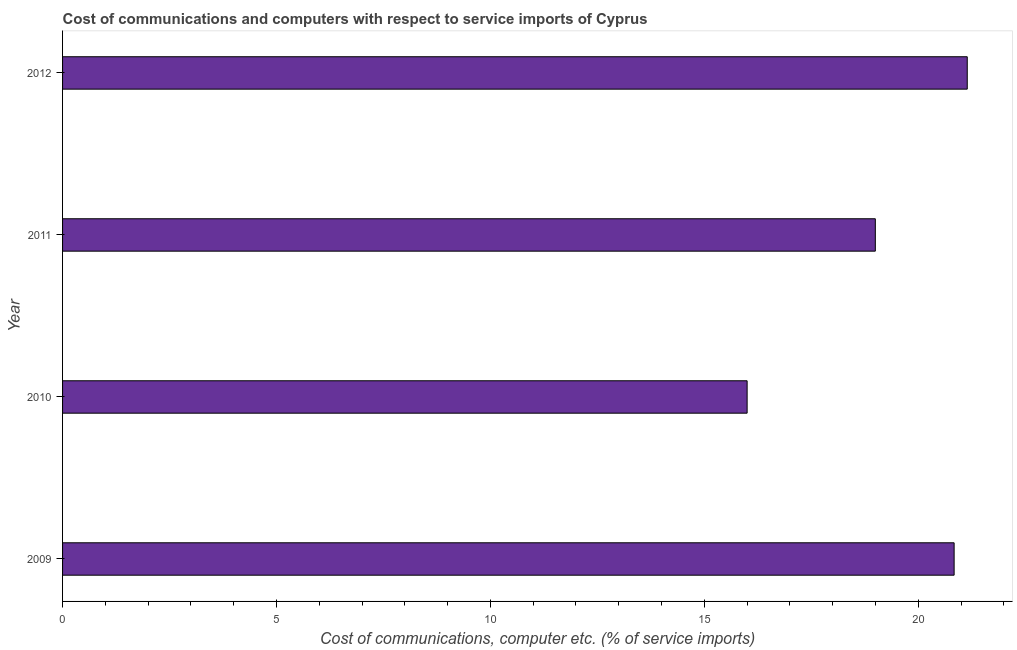Does the graph contain any zero values?
Keep it short and to the point. No. Does the graph contain grids?
Make the answer very short. No. What is the title of the graph?
Make the answer very short. Cost of communications and computers with respect to service imports of Cyprus. What is the label or title of the X-axis?
Keep it short and to the point. Cost of communications, computer etc. (% of service imports). What is the label or title of the Y-axis?
Your answer should be very brief. Year. What is the cost of communications and computer in 2009?
Make the answer very short. 20.84. Across all years, what is the maximum cost of communications and computer?
Provide a succinct answer. 21.15. Across all years, what is the minimum cost of communications and computer?
Provide a short and direct response. 16. What is the sum of the cost of communications and computer?
Your response must be concise. 76.98. What is the difference between the cost of communications and computer in 2009 and 2010?
Your response must be concise. 4.84. What is the average cost of communications and computer per year?
Give a very brief answer. 19.25. What is the median cost of communications and computer?
Keep it short and to the point. 19.92. In how many years, is the cost of communications and computer greater than 7 %?
Make the answer very short. 4. What is the ratio of the cost of communications and computer in 2010 to that in 2011?
Offer a very short reply. 0.84. Is the difference between the cost of communications and computer in 2009 and 2010 greater than the difference between any two years?
Give a very brief answer. No. What is the difference between the highest and the second highest cost of communications and computer?
Offer a terse response. 0.31. Is the sum of the cost of communications and computer in 2011 and 2012 greater than the maximum cost of communications and computer across all years?
Keep it short and to the point. Yes. What is the difference between the highest and the lowest cost of communications and computer?
Ensure brevity in your answer.  5.15. How many bars are there?
Your answer should be very brief. 4. Are all the bars in the graph horizontal?
Offer a terse response. Yes. How many years are there in the graph?
Your response must be concise. 4. Are the values on the major ticks of X-axis written in scientific E-notation?
Your answer should be compact. No. What is the Cost of communications, computer etc. (% of service imports) in 2009?
Give a very brief answer. 20.84. What is the Cost of communications, computer etc. (% of service imports) of 2010?
Make the answer very short. 16. What is the Cost of communications, computer etc. (% of service imports) in 2011?
Give a very brief answer. 19. What is the Cost of communications, computer etc. (% of service imports) of 2012?
Make the answer very short. 21.15. What is the difference between the Cost of communications, computer etc. (% of service imports) in 2009 and 2010?
Offer a very short reply. 4.84. What is the difference between the Cost of communications, computer etc. (% of service imports) in 2009 and 2011?
Your answer should be very brief. 1.84. What is the difference between the Cost of communications, computer etc. (% of service imports) in 2009 and 2012?
Make the answer very short. -0.31. What is the difference between the Cost of communications, computer etc. (% of service imports) in 2010 and 2011?
Make the answer very short. -3. What is the difference between the Cost of communications, computer etc. (% of service imports) in 2010 and 2012?
Keep it short and to the point. -5.15. What is the difference between the Cost of communications, computer etc. (% of service imports) in 2011 and 2012?
Your response must be concise. -2.15. What is the ratio of the Cost of communications, computer etc. (% of service imports) in 2009 to that in 2010?
Give a very brief answer. 1.3. What is the ratio of the Cost of communications, computer etc. (% of service imports) in 2009 to that in 2011?
Keep it short and to the point. 1.1. What is the ratio of the Cost of communications, computer etc. (% of service imports) in 2010 to that in 2011?
Your response must be concise. 0.84. What is the ratio of the Cost of communications, computer etc. (% of service imports) in 2010 to that in 2012?
Offer a terse response. 0.76. What is the ratio of the Cost of communications, computer etc. (% of service imports) in 2011 to that in 2012?
Provide a short and direct response. 0.9. 